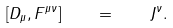Convert formula to latex. <formula><loc_0><loc_0><loc_500><loc_500>[ D _ { \mu } , F ^ { \mu \nu } ] \quad = \quad J ^ { \nu } .</formula> 